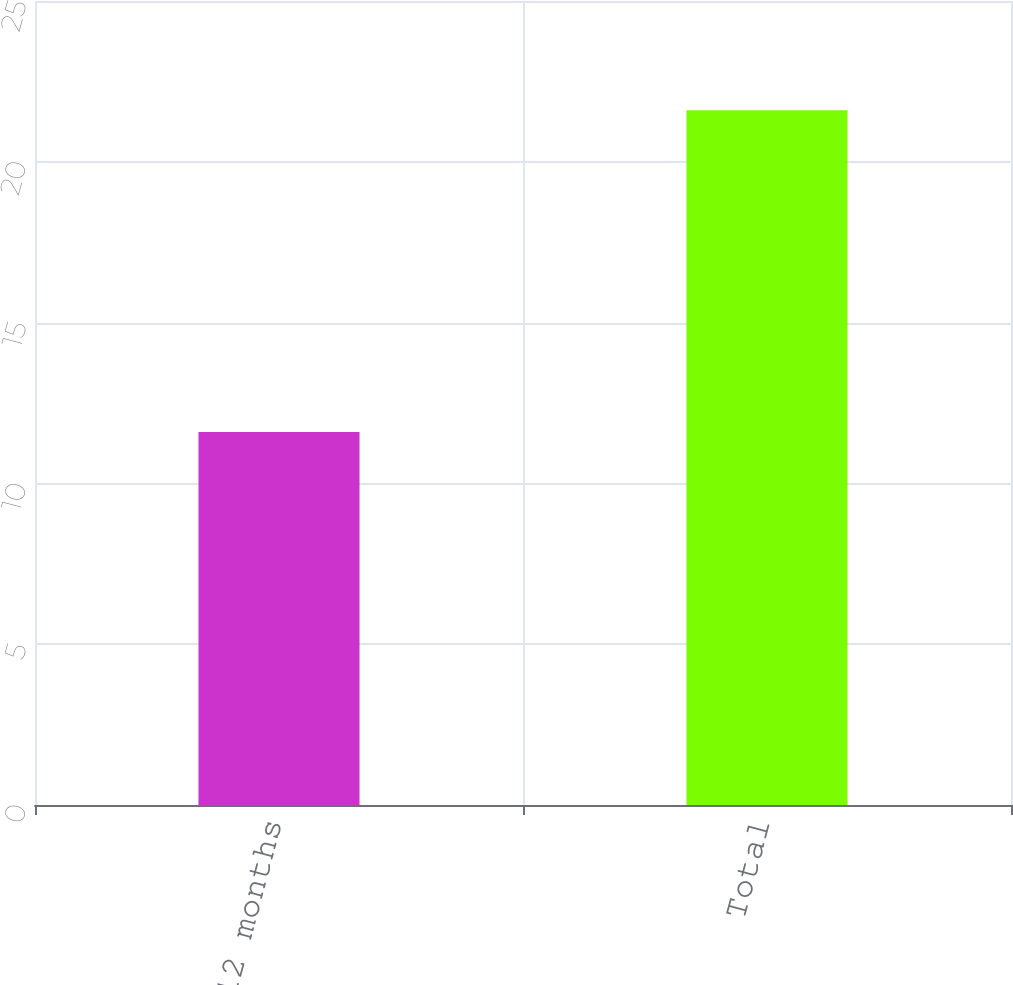Convert chart. <chart><loc_0><loc_0><loc_500><loc_500><bar_chart><fcel>Less than 12 months<fcel>Total<nl><fcel>11.6<fcel>21.6<nl></chart> 